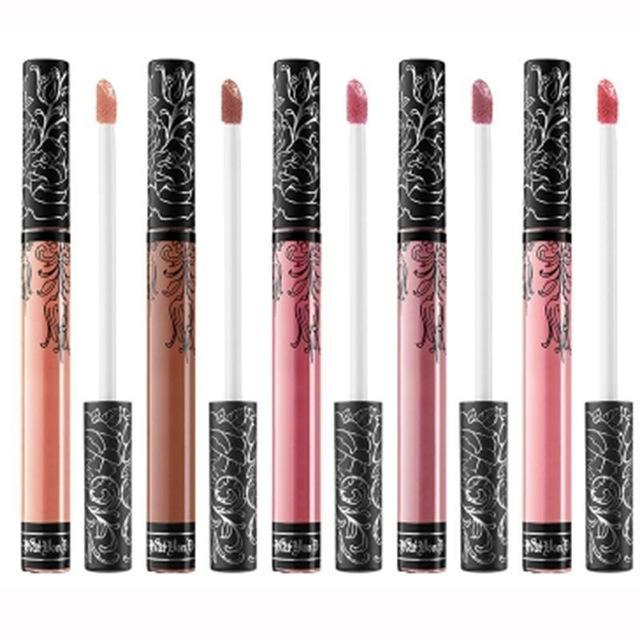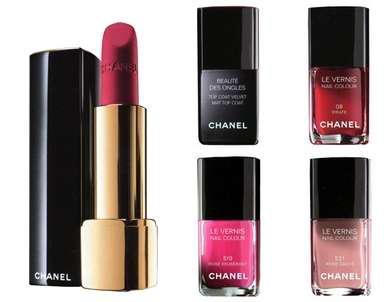The first image is the image on the left, the second image is the image on the right. For the images displayed, is the sentence "There are no more than four lipsticks in the image on the left." factually correct? Answer yes or no. No. The first image is the image on the left, the second image is the image on the right. Given the left and right images, does the statement "The left image shows at least four traditional lipsticks." hold true? Answer yes or no. No. 